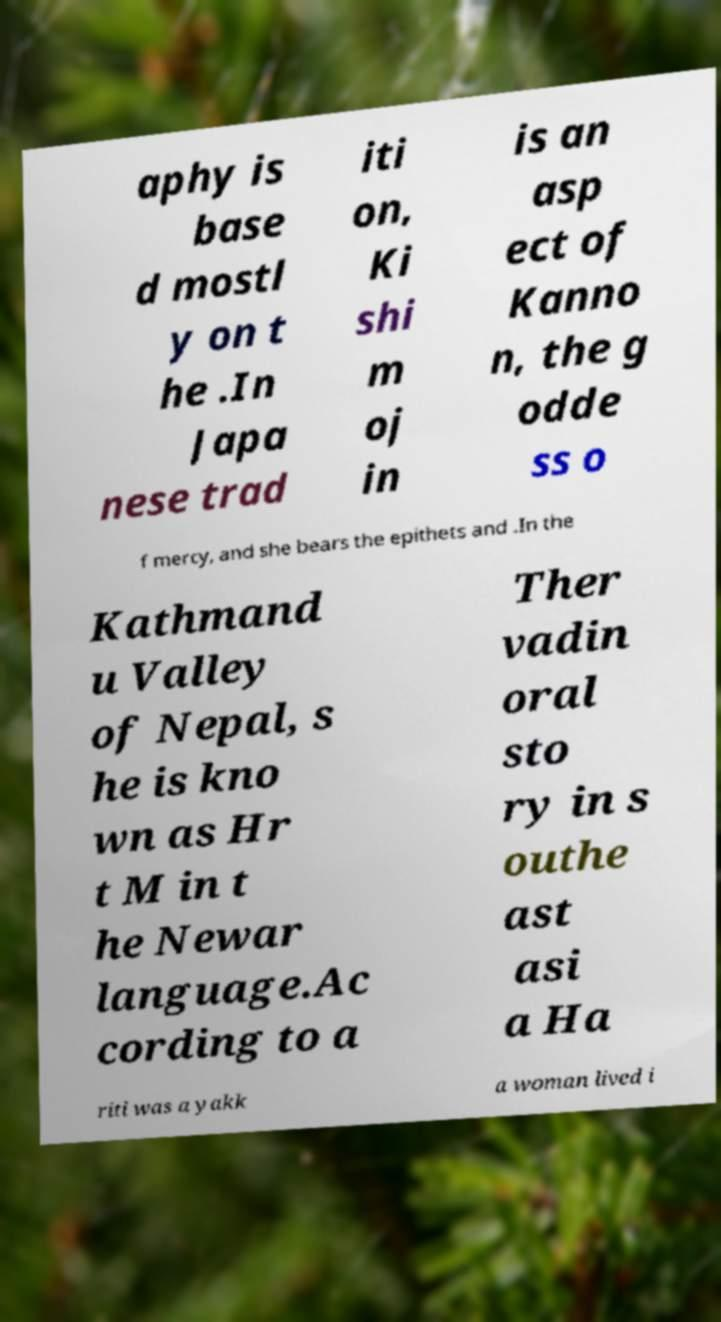For documentation purposes, I need the text within this image transcribed. Could you provide that? aphy is base d mostl y on t he .In Japa nese trad iti on, Ki shi m oj in is an asp ect of Kanno n, the g odde ss o f mercy, and she bears the epithets and .In the Kathmand u Valley of Nepal, s he is kno wn as Hr t M in t he Newar language.Ac cording to a Ther vadin oral sto ry in s outhe ast asi a Ha riti was a yakk a woman lived i 